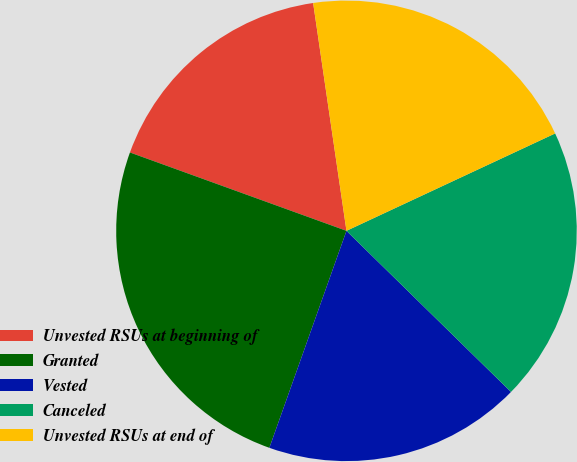Convert chart. <chart><loc_0><loc_0><loc_500><loc_500><pie_chart><fcel>Unvested RSUs at beginning of<fcel>Granted<fcel>Vested<fcel>Canceled<fcel>Unvested RSUs at end of<nl><fcel>17.16%<fcel>25.09%<fcel>18.1%<fcel>19.28%<fcel>20.36%<nl></chart> 